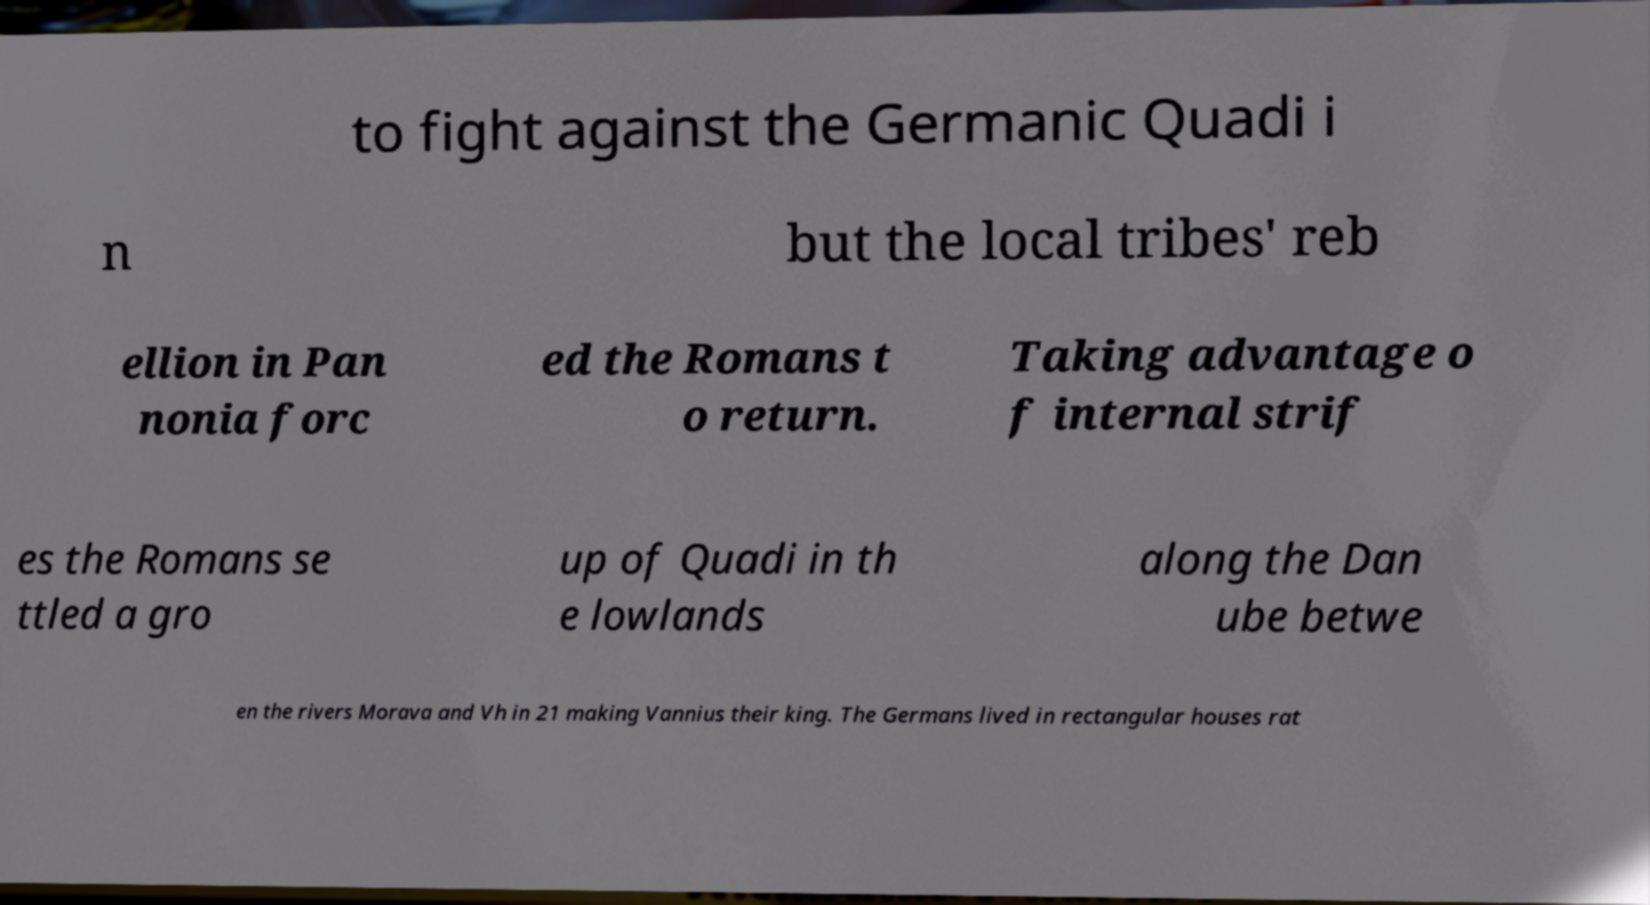Can you accurately transcribe the text from the provided image for me? to fight against the Germanic Quadi i n but the local tribes' reb ellion in Pan nonia forc ed the Romans t o return. Taking advantage o f internal strif es the Romans se ttled a gro up of Quadi in th e lowlands along the Dan ube betwe en the rivers Morava and Vh in 21 making Vannius their king. The Germans lived in rectangular houses rat 